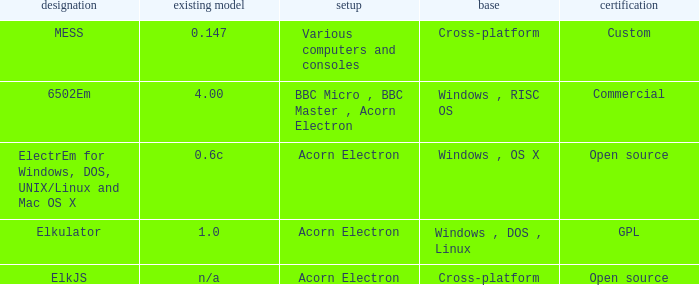Which system is named ELKJS? Acorn Electron. 